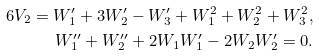<formula> <loc_0><loc_0><loc_500><loc_500>6 V _ { 2 } = W ^ { \prime } _ { 1 } + 3 W ^ { \prime } _ { 2 } - W ^ { \prime } _ { 3 } + W _ { 1 } ^ { 2 } + W _ { 2 } ^ { 2 } + W _ { 3 } ^ { 2 } , \\ W ^ { \prime \prime } _ { 1 } + W ^ { \prime \prime } _ { 2 } + 2 W _ { 1 } W ^ { \prime } _ { 1 } - 2 W _ { 2 } W ^ { \prime } _ { 2 } = 0 .</formula> 